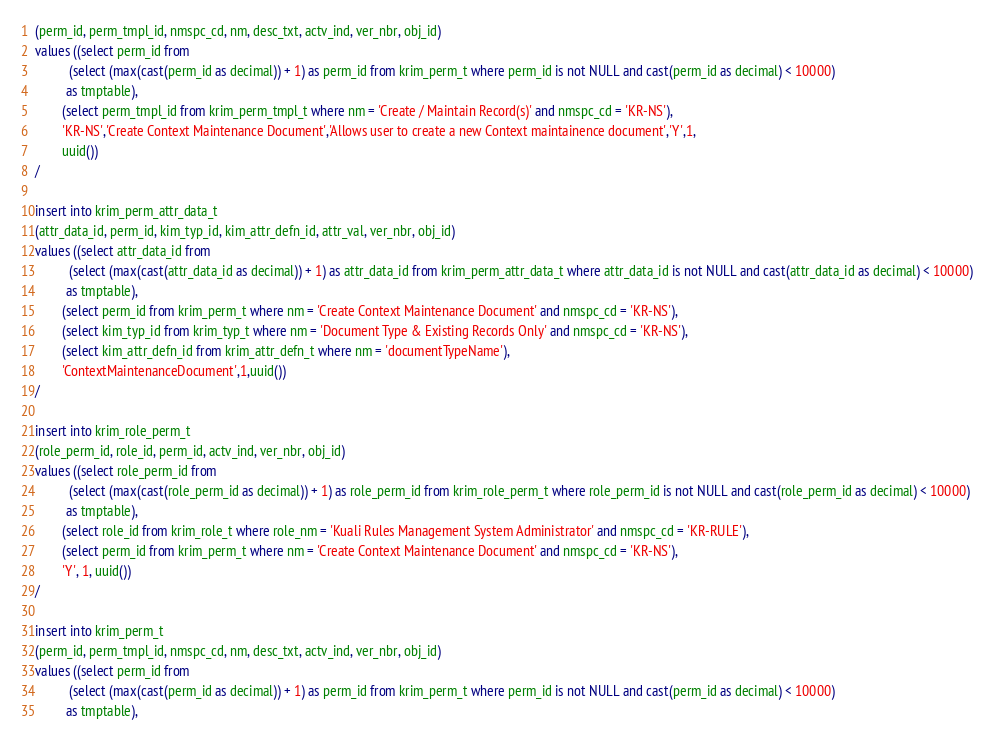Convert code to text. <code><loc_0><loc_0><loc_500><loc_500><_SQL_>(perm_id, perm_tmpl_id, nmspc_cd, nm, desc_txt, actv_ind, ver_nbr, obj_id)
values ((select perm_id from
          (select (max(cast(perm_id as decimal)) + 1) as perm_id from krim_perm_t where perm_id is not NULL and cast(perm_id as decimal) < 10000)
         as tmptable),
        (select perm_tmpl_id from krim_perm_tmpl_t where nm = 'Create / Maintain Record(s)' and nmspc_cd = 'KR-NS'),
        'KR-NS','Create Context Maintenance Document','Allows user to create a new Context maintainence document','Y',1,
        uuid())
/

insert into krim_perm_attr_data_t
(attr_data_id, perm_id, kim_typ_id, kim_attr_defn_id, attr_val, ver_nbr, obj_id)
values ((select attr_data_id from
          (select (max(cast(attr_data_id as decimal)) + 1) as attr_data_id from krim_perm_attr_data_t where attr_data_id is not NULL and cast(attr_data_id as decimal) < 10000)
         as tmptable),
        (select perm_id from krim_perm_t where nm = 'Create Context Maintenance Document' and nmspc_cd = 'KR-NS'),
        (select kim_typ_id from krim_typ_t where nm = 'Document Type & Existing Records Only' and nmspc_cd = 'KR-NS'),
        (select kim_attr_defn_id from krim_attr_defn_t where nm = 'documentTypeName'),
        'ContextMaintenanceDocument',1,uuid())
/

insert into krim_role_perm_t
(role_perm_id, role_id, perm_id, actv_ind, ver_nbr, obj_id)
values ((select role_perm_id from
          (select (max(cast(role_perm_id as decimal)) + 1) as role_perm_id from krim_role_perm_t where role_perm_id is not NULL and cast(role_perm_id as decimal) < 10000)
         as tmptable),
        (select role_id from krim_role_t where role_nm = 'Kuali Rules Management System Administrator' and nmspc_cd = 'KR-RULE'),
        (select perm_id from krim_perm_t where nm = 'Create Context Maintenance Document' and nmspc_cd = 'KR-NS'),
        'Y', 1, uuid())
/

insert into krim_perm_t
(perm_id, perm_tmpl_id, nmspc_cd, nm, desc_txt, actv_ind, ver_nbr, obj_id)
values ((select perm_id from
          (select (max(cast(perm_id as decimal)) + 1) as perm_id from krim_perm_t where perm_id is not NULL and cast(perm_id as decimal) < 10000)
         as tmptable),</code> 